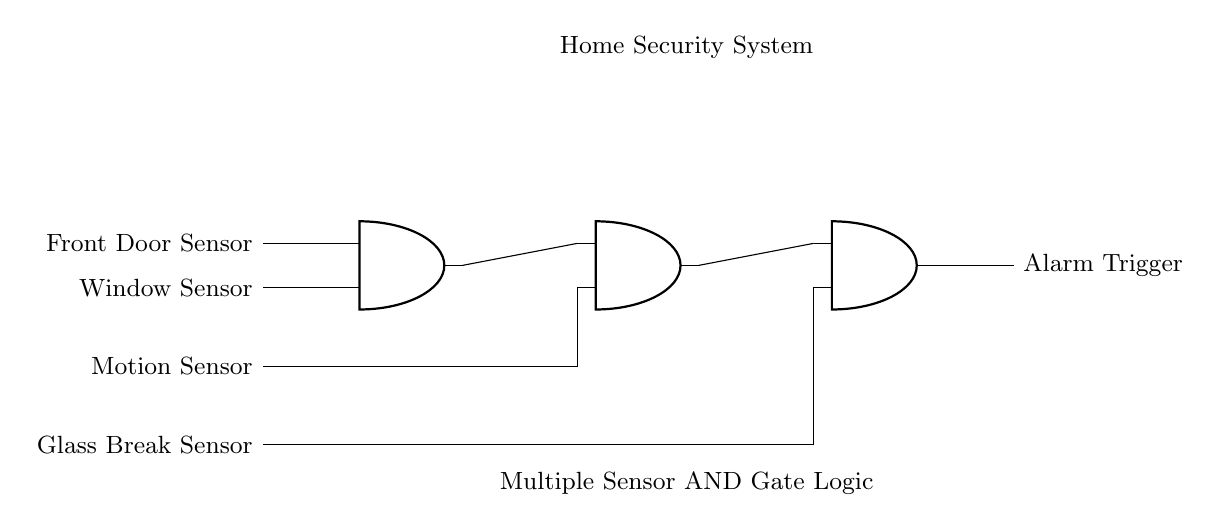What are the inputs for the first AND gate? The first AND gate has two inputs: a front door sensor and a window sensor. These are the elements connected to the input terminals of the first gate, which are necessary for the security system logic.
Answer: Front door sensor, Window sensor What does the output of the last AND gate trigger? The output of the last AND gate triggers the alarm. This is the response generated when all previous sensor conditions are met, indicating a potential security breach.
Answer: Alarm Trigger How many sensors must be activated to trigger the alarm? All four sensors need to be activated to ensure that the alarm goes off. This is a crucial aspect of the design, as it prevents false alarms by requiring multiple confirmations before triggering.
Answer: Four sensors Which sensor is associated directly with the second AND gate? The motion sensor is directly associated with the second AND gate. It connects to the second terminal of the gate, linking its activation with the output of the first gate.
Answer: Motion Sensor What is the arrangement of the sensors in the circuit? The sensors are arranged in a sequence, where the output of each AND gate is connected as an input to the next AND gate. This cascaded arrangement ensures that all sensors must be triggered for the final alarm output.
Answer: Series connection What type of logic does this circuit employ? The circuit employs AND logic, which means that all inputs must be true (or activated) for the output to also be true (or the alarm to trigger). The reliance on multiple sensor inputs characterizes this logic type.
Answer: AND logic 